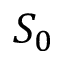<formula> <loc_0><loc_0><loc_500><loc_500>S _ { 0 }</formula> 